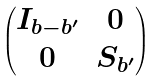Convert formula to latex. <formula><loc_0><loc_0><loc_500><loc_500>\begin{pmatrix} I _ { b - b ^ { \prime } } & 0 \\ 0 & S _ { b ^ { \prime } } \end{pmatrix}</formula> 